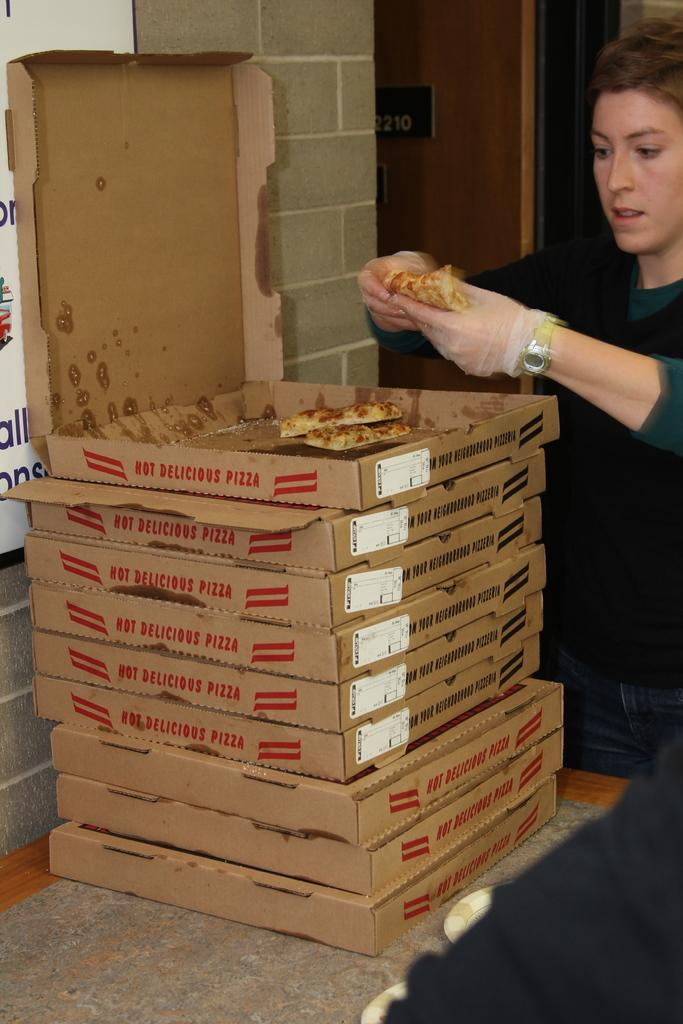<image>
Share a concise interpretation of the image provided. A stack of pizza boxes with Hot Delicious Pizza written on the side of the boxes 